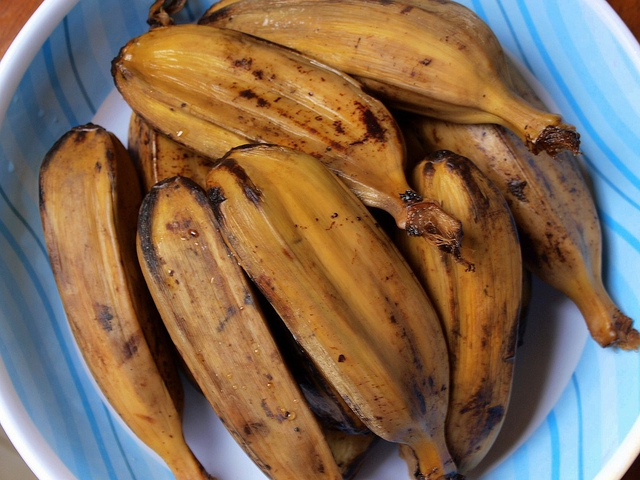Describe the objects in this image and their specific colors. I can see bowl in brown, black, maroon, tan, and gray tones, banana in brown, olive, maroon, and orange tones, banana in brown, red, orange, tan, and maroon tones, banana in brown, tan, black, and gray tones, and banana in brown, tan, olive, and maroon tones in this image. 